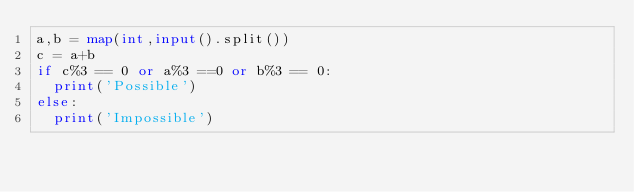Convert code to text. <code><loc_0><loc_0><loc_500><loc_500><_Python_>a,b = map(int,input().split())
c = a+b
if c%3 == 0 or a%3 ==0 or b%3 == 0:
  print('Possible')
else:
  print('Impossible')</code> 